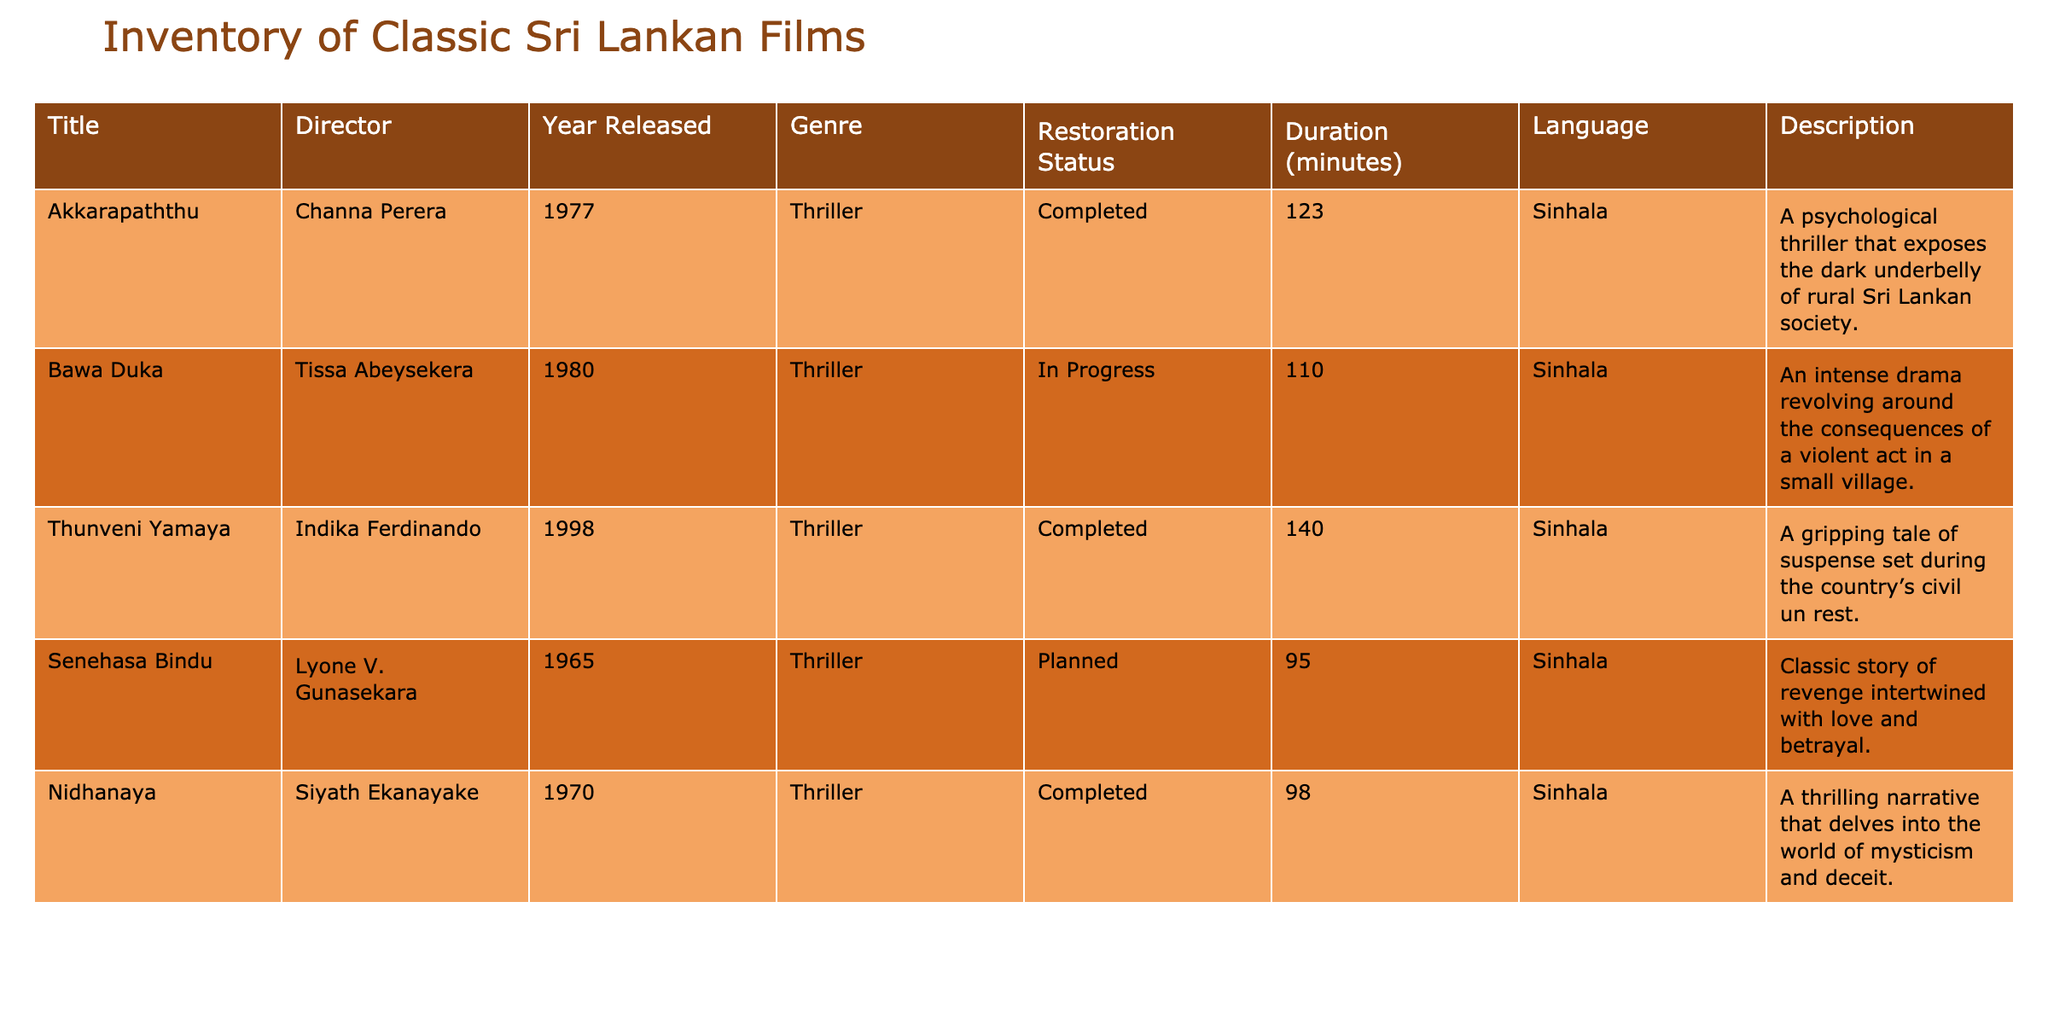What is the title of the film directed by Tissa Abeysekera? The title can be found in the corresponding row under the "Director" column for Tissa Abeysekera. That row shows "Bawa Duka".
Answer: Bawa Duka How many minutes long is "Thunveni Yamaya"? The duration of "Thunveni Yamaya" can be directly found in the "Duration" column. It is listed as 140 minutes.
Answer: 140 Is "Nidhanaya" completed? The "Restoration Status" column shows that "Nidhanaya" is marked as "Completed".
Answer: Yes What is the longest film in this inventory? We look at the "Duration" column and determine that "Thunveni Yamaya" with a duration of 140 minutes is the longest.
Answer: Thunveni Yamaya What is the average duration of the films that are marked as "Completed"? The completed films are "Akkarapaththu" (123), "Thunveni Yamaya" (140), and "Nidhanaya" (98). The sum is (123 + 140 + 98) = 361, and the average is 361 / 3 = 120.33.
Answer: 120.33 Which film was released the earliest? By checking the "Year Released" column, we find that "Senehasa Bindu" was released in 1965, which is earlier than the others.
Answer: Senehasa Bindu Are there more films classified as "Thriller" or "Drama" in this inventory? All films listed are classified as "Thriller," so there are no "Drama" films in the inventory. Thus, more films are classified as "Thriller".
Answer: Thriller How many films have a restoration status listed as "Planned"? In the "Restoration Status" column, we look for the "Planned" status and count, finding that there is one film: "Senehasa Bindu".
Answer: 1 What is the total number of films that are currently “In Progress”? By checking the "Restoration Status" column, we see that there is only one film, "Bawa Duka", currently "In Progress".
Answer: 1 